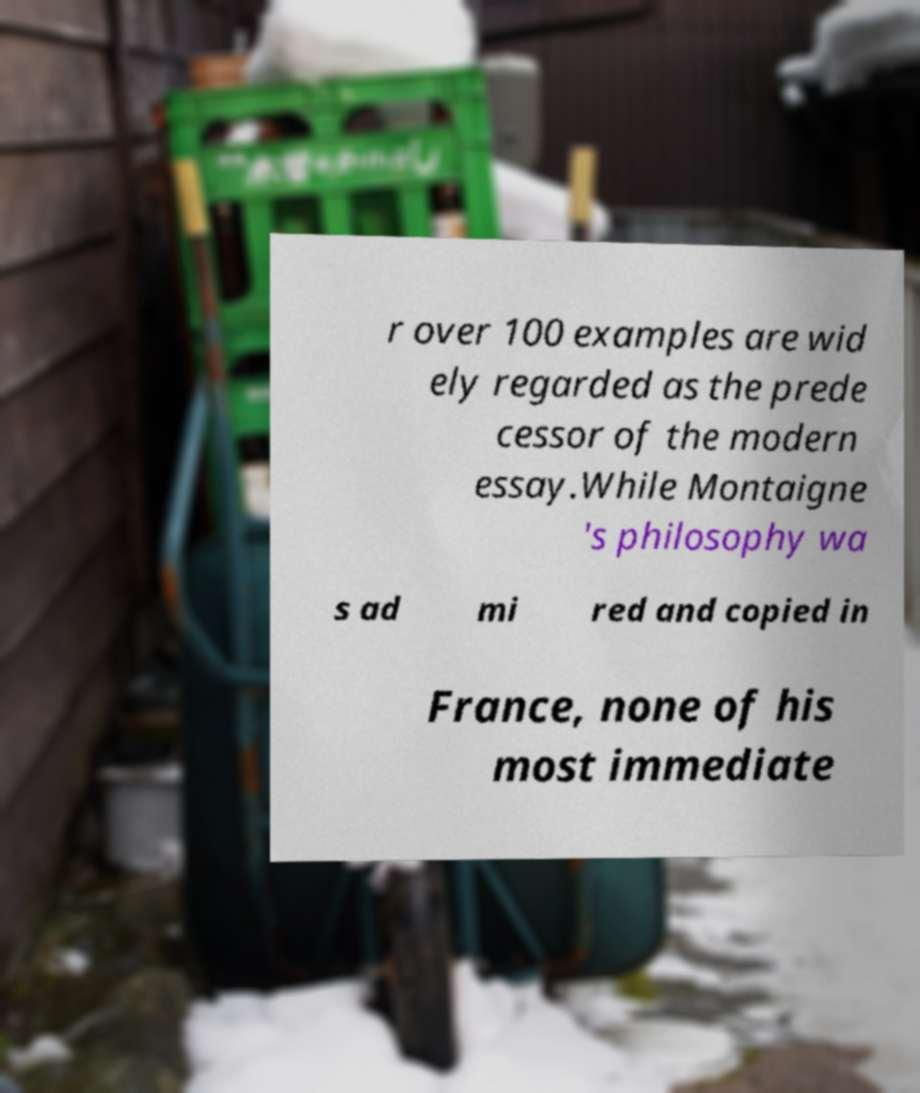Could you extract and type out the text from this image? r over 100 examples are wid ely regarded as the prede cessor of the modern essay.While Montaigne 's philosophy wa s ad mi red and copied in France, none of his most immediate 